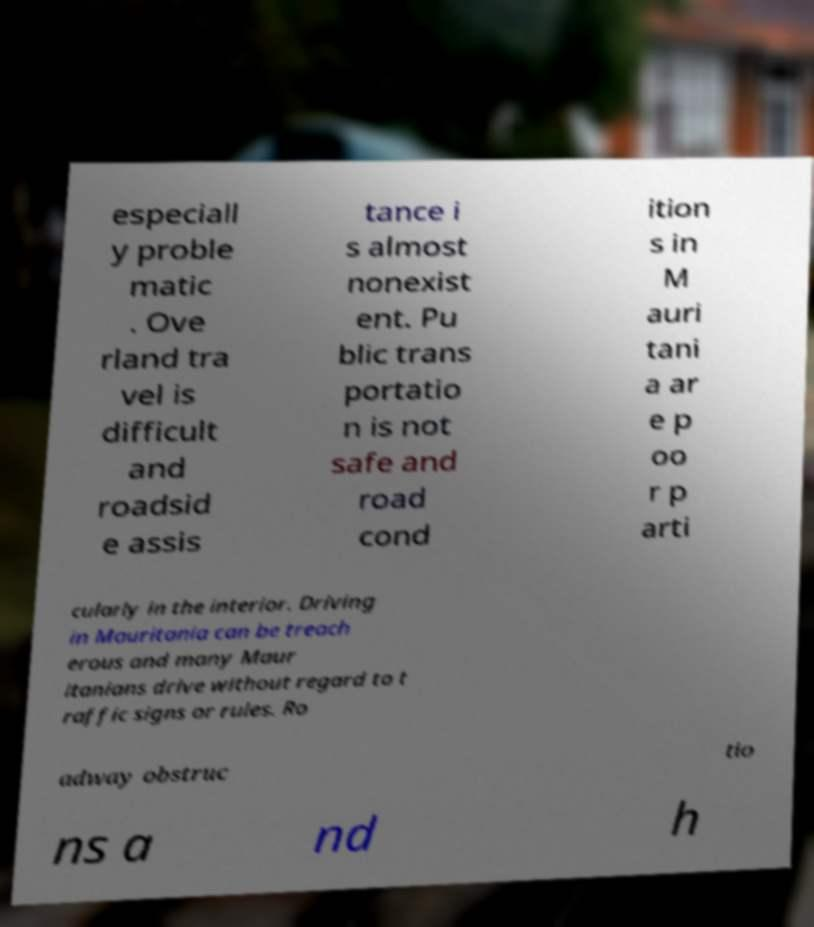There's text embedded in this image that I need extracted. Can you transcribe it verbatim? especiall y proble matic . Ove rland tra vel is difficult and roadsid e assis tance i s almost nonexist ent. Pu blic trans portatio n is not safe and road cond ition s in M auri tani a ar e p oo r p arti cularly in the interior. Driving in Mauritania can be treach erous and many Maur itanians drive without regard to t raffic signs or rules. Ro adway obstruc tio ns a nd h 